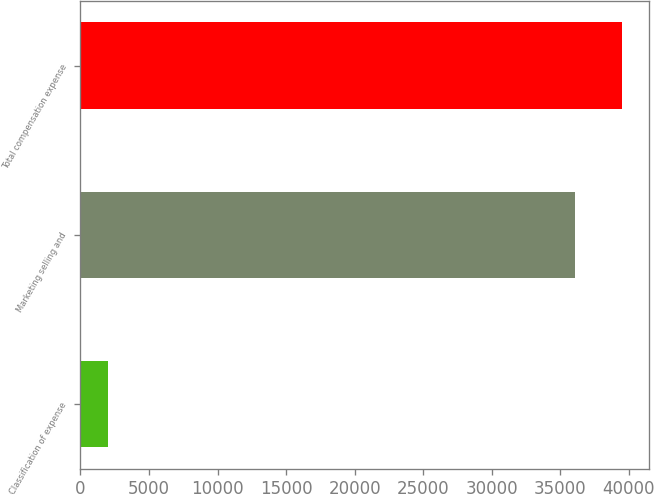Convert chart to OTSL. <chart><loc_0><loc_0><loc_500><loc_500><bar_chart><fcel>Classification of expense<fcel>Marketing selling and<fcel>Total compensation expense<nl><fcel>2015<fcel>36073<fcel>39478.8<nl></chart> 